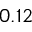<formula> <loc_0><loc_0><loc_500><loc_500>0 . 1 2</formula> 